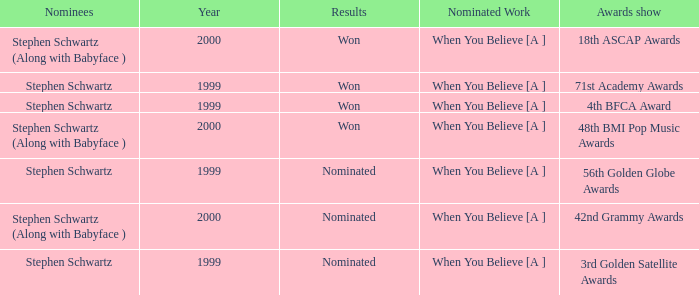What was the results of the 71st Academy Awards show? Won. 